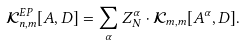<formula> <loc_0><loc_0><loc_500><loc_500>\mathcal { K } _ { n , m } ^ { E P } [ A , D ] = \sum _ { \alpha } Z _ { N } ^ { \alpha } \cdot \mathcal { K } _ { m , m } [ A ^ { \alpha } , D ] .</formula> 